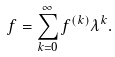<formula> <loc_0><loc_0><loc_500><loc_500>f = \sum _ { k = 0 } ^ { \infty } f ^ { ( k ) } \lambda ^ { k } .</formula> 